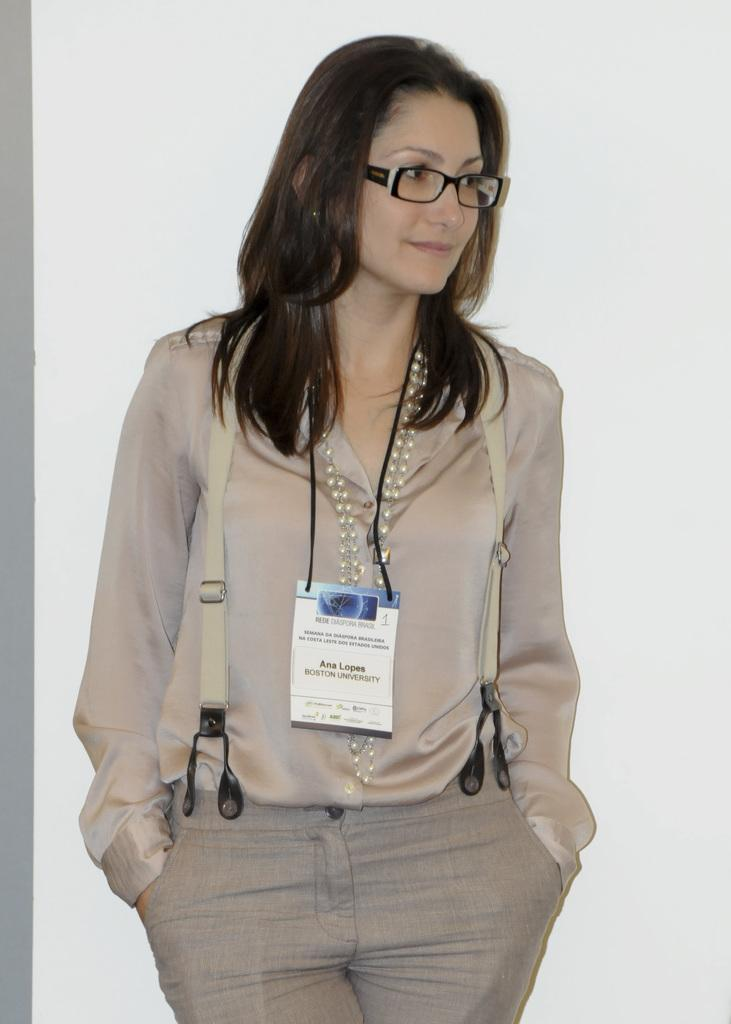What is the main subject of the image? The main subject of the image is a woman. What is the woman doing in the image? The woman is standing in the image. What accessory is the woman wearing in the image? The woman is wearing an ID card in the image. Where is the woman jumping in the park in the image? There is no park or jumping woman present in the image; it features a woman standing and wearing an ID card. What type of shoes is the woman wearing in the image? The type of shoes the woman is wearing is not visible in the image. 